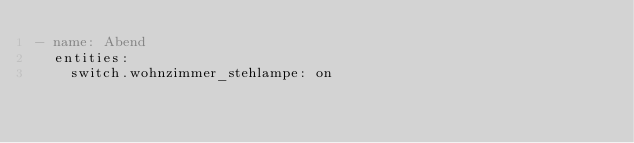<code> <loc_0><loc_0><loc_500><loc_500><_YAML_>- name: Abend
  entities:
    switch.wohnzimmer_stehlampe: on
</code> 